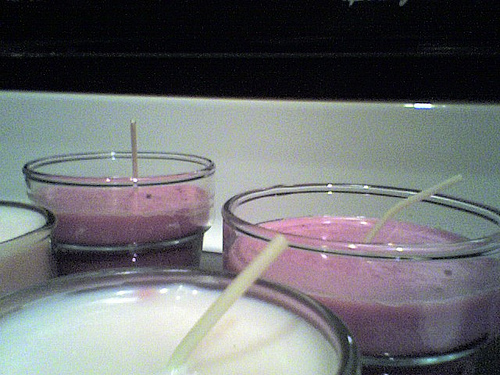<image>
Is the pink candle behind the white candle? Yes. From this viewpoint, the pink candle is positioned behind the white candle, with the white candle partially or fully occluding the pink candle. 